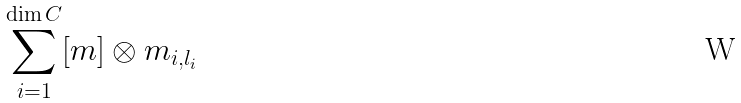<formula> <loc_0><loc_0><loc_500><loc_500>\sum _ { i = 1 } ^ { \dim C } [ m ] \otimes m _ { i , l _ { i } }</formula> 